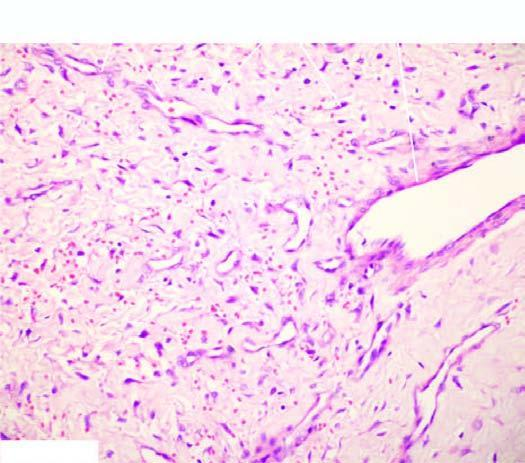what has stellate fibroblasts and mast cells?
Answer the question using a single word or phrase. Stroma 